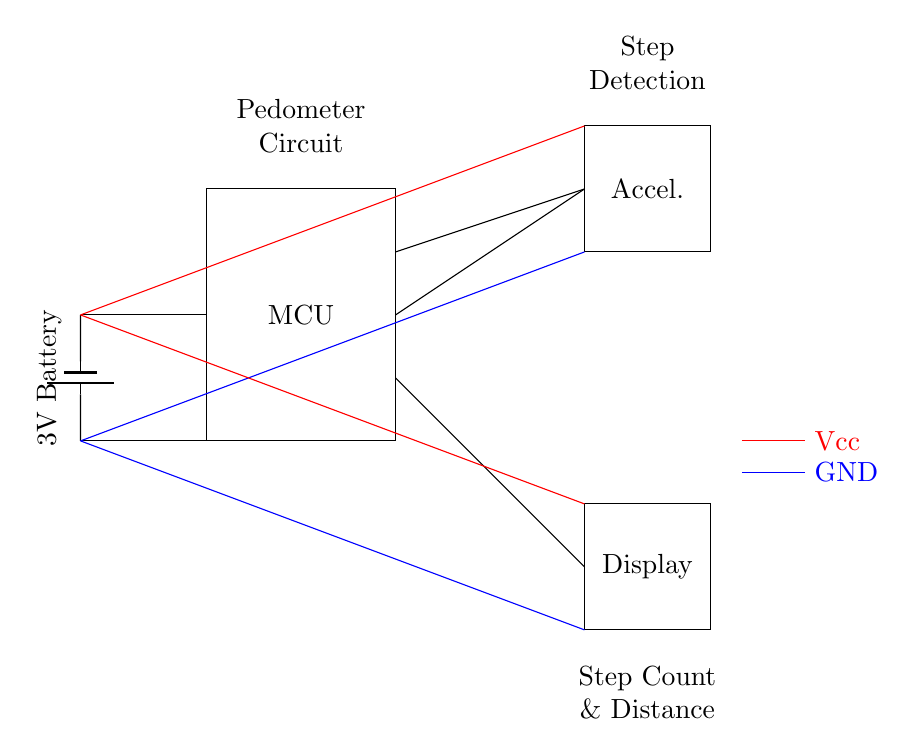What type of microcontroller is used in this circuit? The circuit does not specify a particular type of microcontroller, but it's a generic MCU used for processing input signals from the accelerometer and managing the display.
Answer: MCU What is the purpose of the accelerometer in this circuit? The accelerometer detects motion and changes in orientation, which is essential for counting steps accurately. It provides input data to the microcontroller for step detection.
Answer: Step detection What are the power supply voltages for this circuit? The circuit uses a 3V battery as the power supply; 3V is indicated near the battery symbol.
Answer: 3V How many connections does the MCU have with the accelerometer? The MCU has two connections to the accelerometer: one for step detection and another for providing power or ground. This is shown by two lines originating from the MCU to the accelerometer.
Answer: Two What is the function of the display in this device? The display shows the count of steps and the distance traveled, as indicated in the labeling on the diagram near the display component.
Answer: Showing step count and distance What is the significance of the ground symbol in the circuit? The ground symbol indicates the reference point of the circuit where all voltages are measured; it provides a common return path for electric current, essential for the circuit's functionality.
Answer: Common return path What type of signals does the MCU process from the accelerometer? The MCU processes digital signals derived from the motion detected by the accelerometer, converting them into step counts and distance measurements based on predefined algorithms or parameters in the firmware.
Answer: Digital signals 